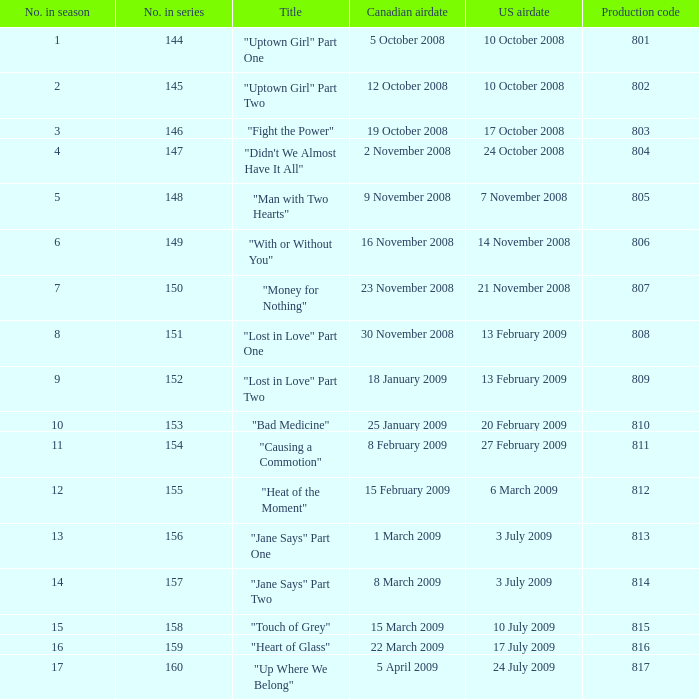What is the latest season number for a show with a production code of 816? 16.0. 